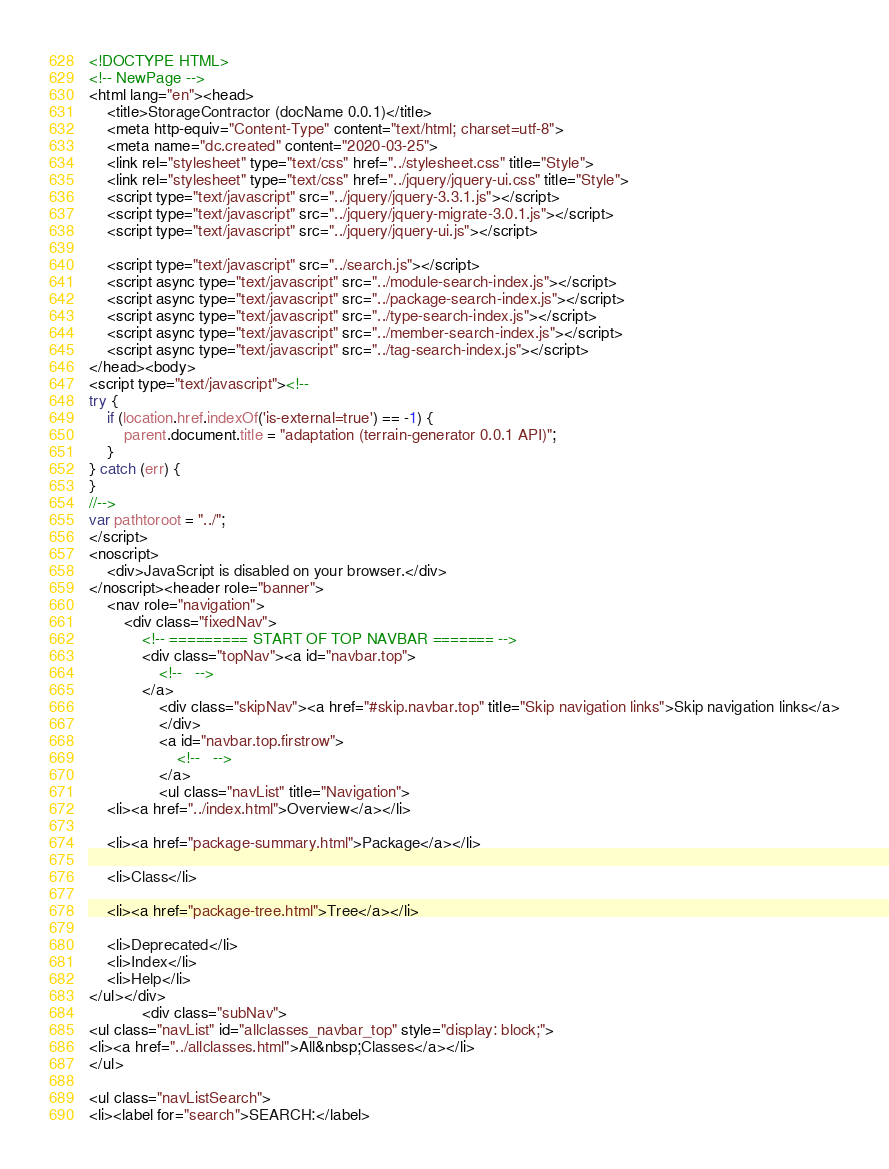<code> <loc_0><loc_0><loc_500><loc_500><_HTML_><!DOCTYPE HTML>
<!-- NewPage -->
<html lang="en"><head>
    <title>StorageContractor (docName 0.0.1)</title>
    <meta http-equiv="Content-Type" content="text/html; charset=utf-8">
    <meta name="dc.created" content="2020-03-25">
    <link rel="stylesheet" type="text/css" href="../stylesheet.css" title="Style">
    <link rel="stylesheet" type="text/css" href="../jquery/jquery-ui.css" title="Style">
    <script type="text/javascript" src="../jquery/jquery-3.3.1.js"></script>
    <script type="text/javascript" src="../jquery/jquery-migrate-3.0.1.js"></script>
    <script type="text/javascript" src="../jquery/jquery-ui.js"></script>

    <script type="text/javascript" src="../search.js"></script>
    <script async type="text/javascript" src="../module-search-index.js"></script>
    <script async type="text/javascript" src="../package-search-index.js"></script>
    <script async type="text/javascript" src="../type-search-index.js"></script>
    <script async type="text/javascript" src="../member-search-index.js"></script>
    <script async type="text/javascript" src="../tag-search-index.js"></script>
</head><body>
<script type="text/javascript"><!--
try {
    if (location.href.indexOf('is-external=true') == -1) {
        parent.document.title = "adaptation (terrain-generator 0.0.1 API)";
    }
} catch (err) {
}
//-->
var pathtoroot = "../";
</script>
<noscript>
    <div>JavaScript is disabled on your browser.</div>
</noscript><header role="banner">
    <nav role="navigation">
        <div class="fixedNav">
            <!-- ========= START OF TOP NAVBAR ======= -->
            <div class="topNav"><a id="navbar.top">
                <!--   -->
            </a>
                <div class="skipNav"><a href="#skip.navbar.top" title="Skip navigation links">Skip navigation links</a>
                </div>
                <a id="navbar.top.firstrow">
                    <!--   -->
                </a>
                <ul class="navList" title="Navigation">
    <li><a href="../index.html">Overview</a></li>
    
    <li><a href="package-summary.html">Package</a></li>
    
    <li>Class</li>
    
    <li><a href="package-tree.html">Tree</a></li>
    
    <li>Deprecated</li>
    <li>Index</li>
    <li>Help</li>
</ul></div>
            <div class="subNav">
<ul class="navList" id="allclasses_navbar_top" style="display: block;">
<li><a href="../allclasses.html">All&nbsp;Classes</a></li>
</ul>

<ul class="navListSearch">
<li><label for="search">SEARCH:</label></code> 